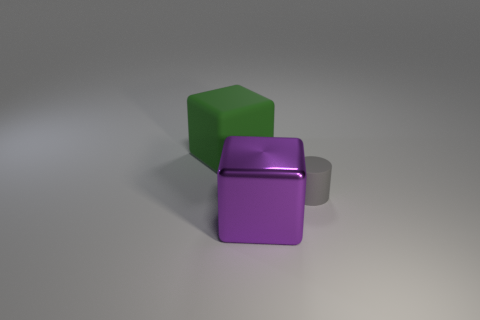Is the block that is right of the rubber cube made of the same material as the gray object? no 